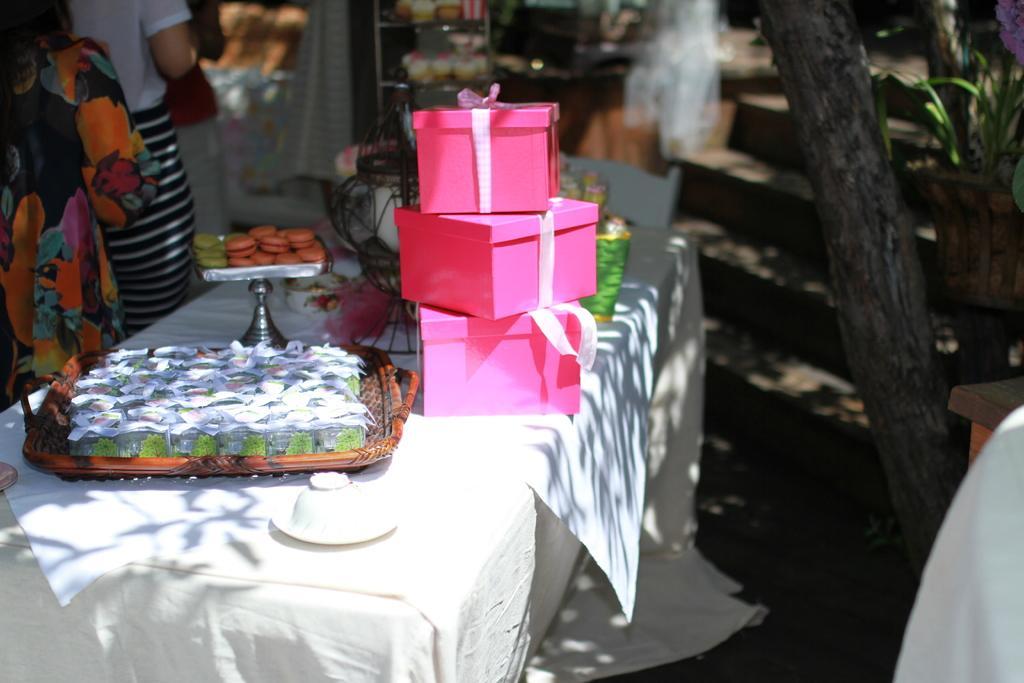Can you describe this image briefly? In the foreground of this image, on the table, there are gift boxes, cakes, boxes on the tray, a white object and few more objects are on the table. In the left, there are two persons. In the background, there are cakes in the rack. On the right, there is a tree and it seems like a person's shoulder and table. 